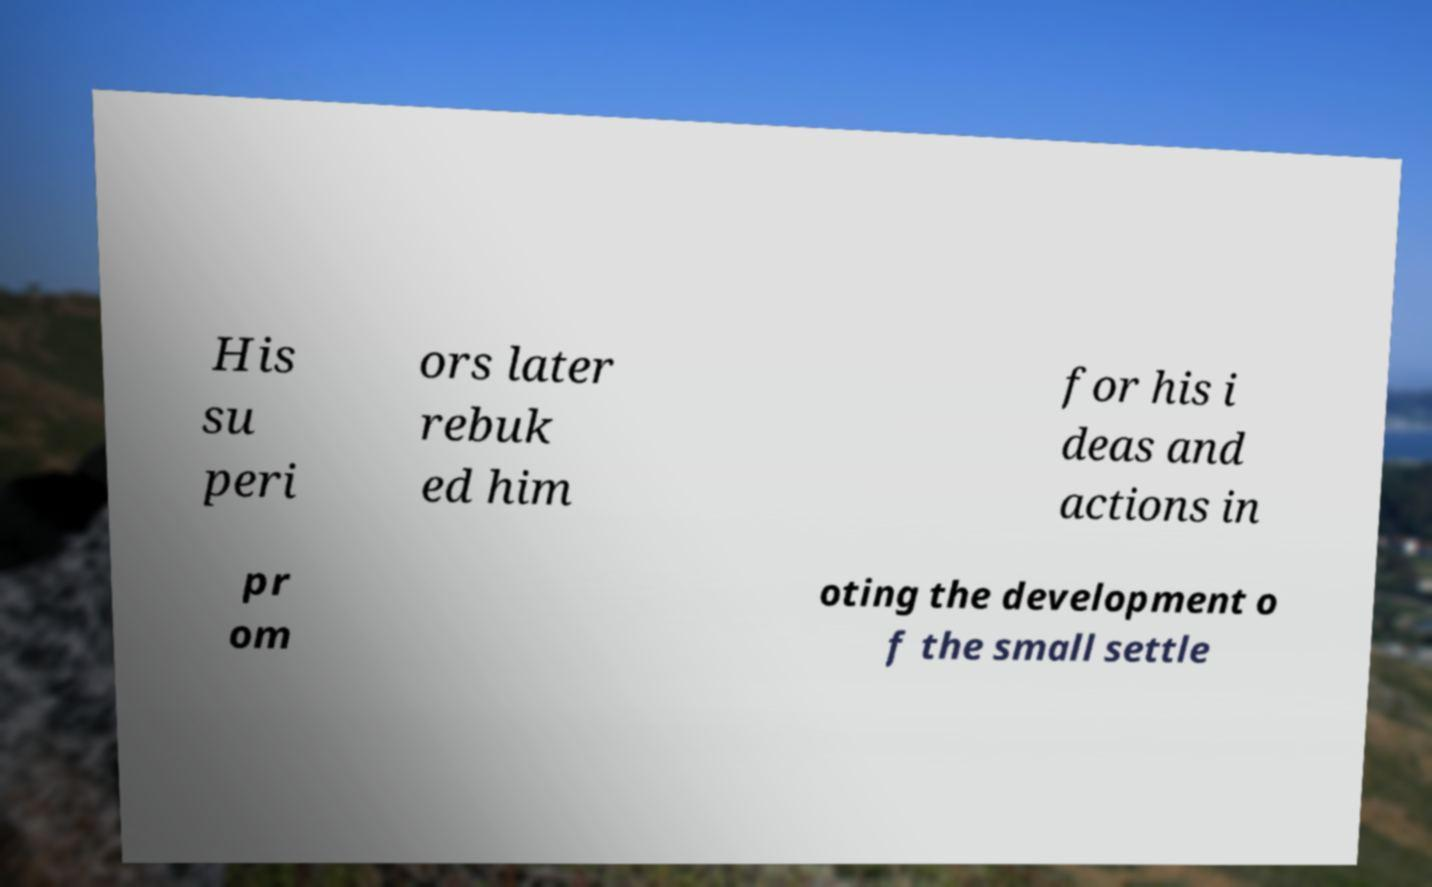Can you read and provide the text displayed in the image?This photo seems to have some interesting text. Can you extract and type it out for me? His su peri ors later rebuk ed him for his i deas and actions in pr om oting the development o f the small settle 